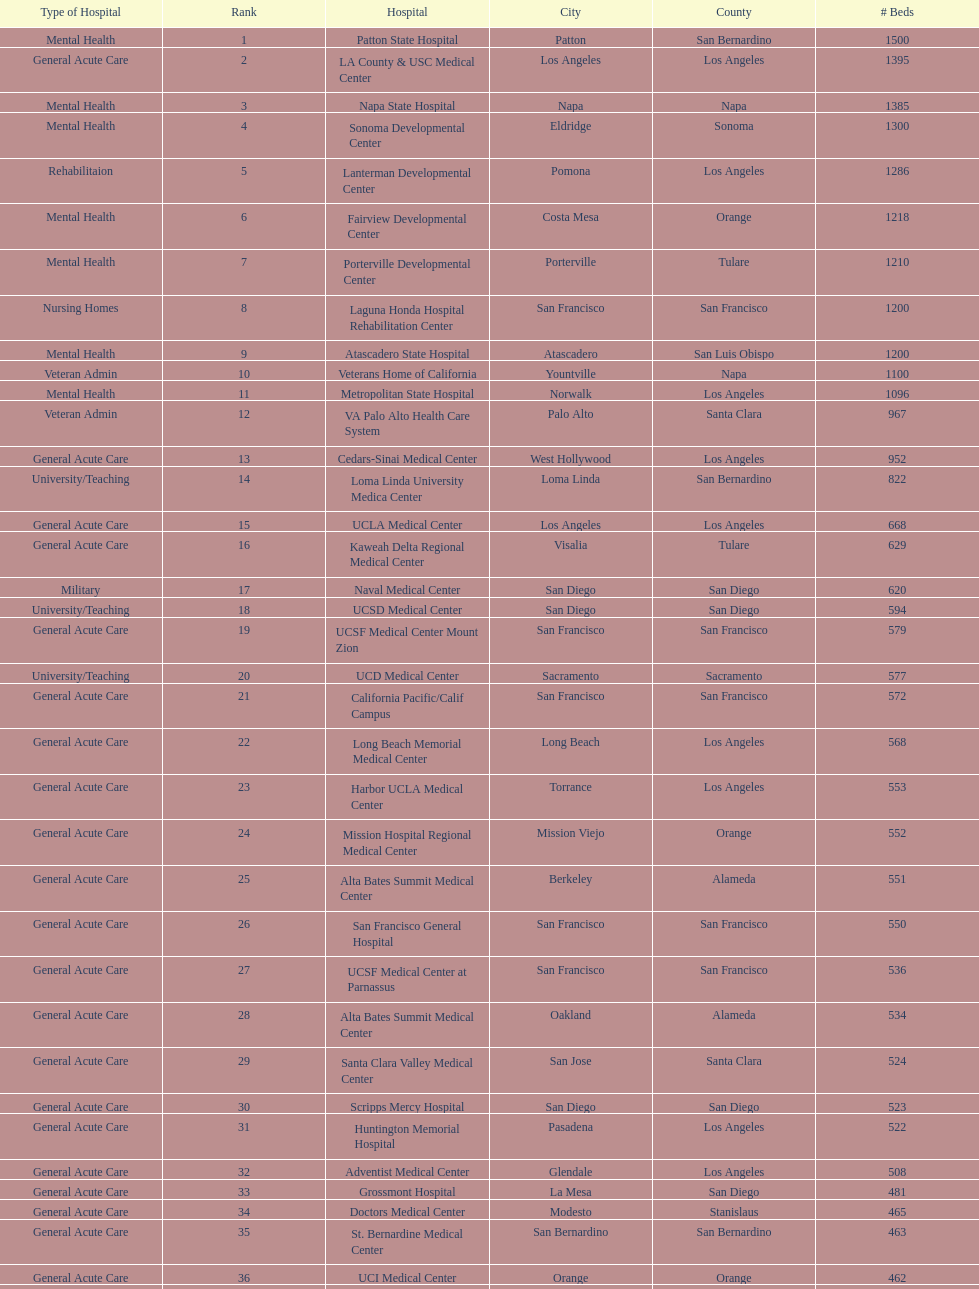Does patton state hospital in the city of patton in san bernardino county have more mental health hospital beds than atascadero state hospital in atascadero, san luis obispo county? Yes. 